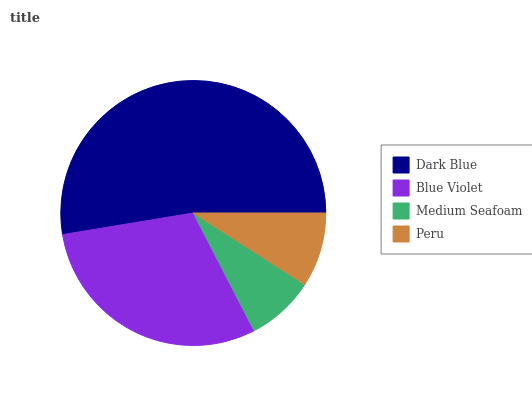Is Medium Seafoam the minimum?
Answer yes or no. Yes. Is Dark Blue the maximum?
Answer yes or no. Yes. Is Blue Violet the minimum?
Answer yes or no. No. Is Blue Violet the maximum?
Answer yes or no. No. Is Dark Blue greater than Blue Violet?
Answer yes or no. Yes. Is Blue Violet less than Dark Blue?
Answer yes or no. Yes. Is Blue Violet greater than Dark Blue?
Answer yes or no. No. Is Dark Blue less than Blue Violet?
Answer yes or no. No. Is Blue Violet the high median?
Answer yes or no. Yes. Is Peru the low median?
Answer yes or no. Yes. Is Dark Blue the high median?
Answer yes or no. No. Is Dark Blue the low median?
Answer yes or no. No. 